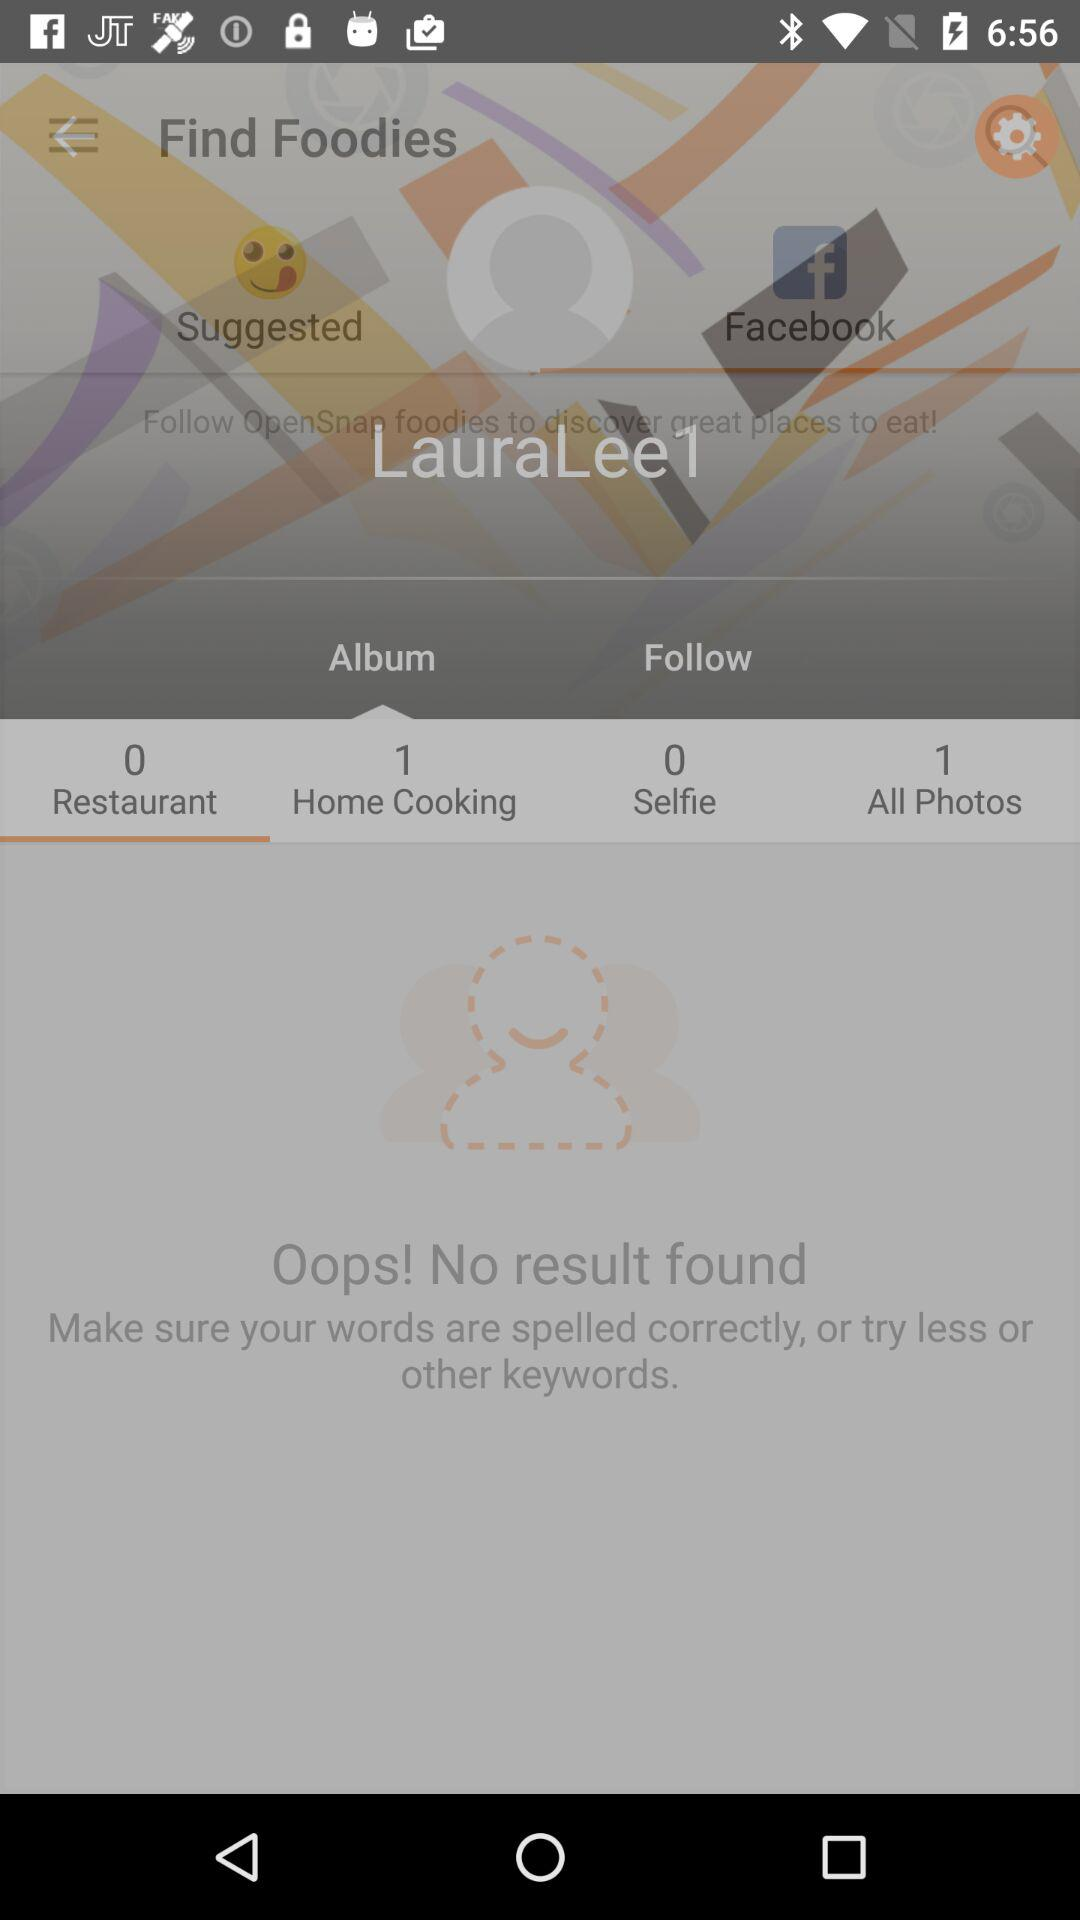What is the number of photos? The number of photos is 1. 